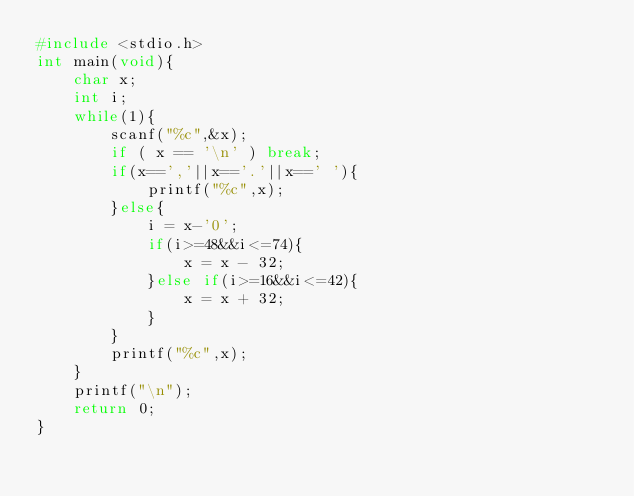<code> <loc_0><loc_0><loc_500><loc_500><_C_>#include <stdio.h>
int main(void){
    char x;
    int i;
    while(1){
        scanf("%c",&x);
        if ( x == '\n' ) break;
        if(x==','||x=='.'||x==' '){
            printf("%c",x);
        }else{
            i = x-'0';
            if(i>=48&&i<=74){
                x = x - 32;
            }else if(i>=16&&i<=42){
                x = x + 32;
            }
        }
        printf("%c",x);
    }
    printf("\n");
    return 0;
}</code> 